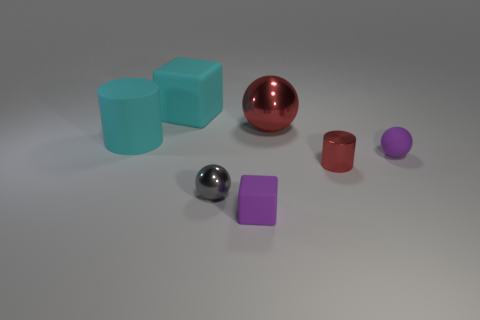What is the material of the thing that is the same color as the big cylinder?
Offer a terse response. Rubber. What is the size of the cylinder that is left of the red ball?
Your response must be concise. Large. There is a purple matte sphere that is behind the tiny gray shiny thing; is there a big matte cylinder behind it?
Provide a short and direct response. Yes. How many other objects are the same shape as the big red metal object?
Provide a short and direct response. 2. Is the shape of the gray thing the same as the large red object?
Offer a terse response. Yes. What color is the small thing that is left of the red cylinder and behind the tiny purple block?
Your response must be concise. Gray. There is a shiny sphere that is the same color as the small cylinder; what size is it?
Provide a short and direct response. Large. What number of large objects are purple matte blocks or cyan blocks?
Keep it short and to the point. 1. Are there any other things that have the same color as the tiny matte sphere?
Offer a terse response. Yes. There is a block that is in front of the metal thing behind the large cyan object that is in front of the large matte cube; what is it made of?
Ensure brevity in your answer.  Rubber. 